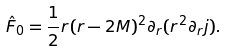Convert formula to latex. <formula><loc_0><loc_0><loc_500><loc_500>\hat { F } _ { 0 } = \frac { 1 } { 2 } r ( r - 2 M ) ^ { 2 } \partial _ { r } ( r ^ { 2 } \partial _ { r } j ) .</formula> 